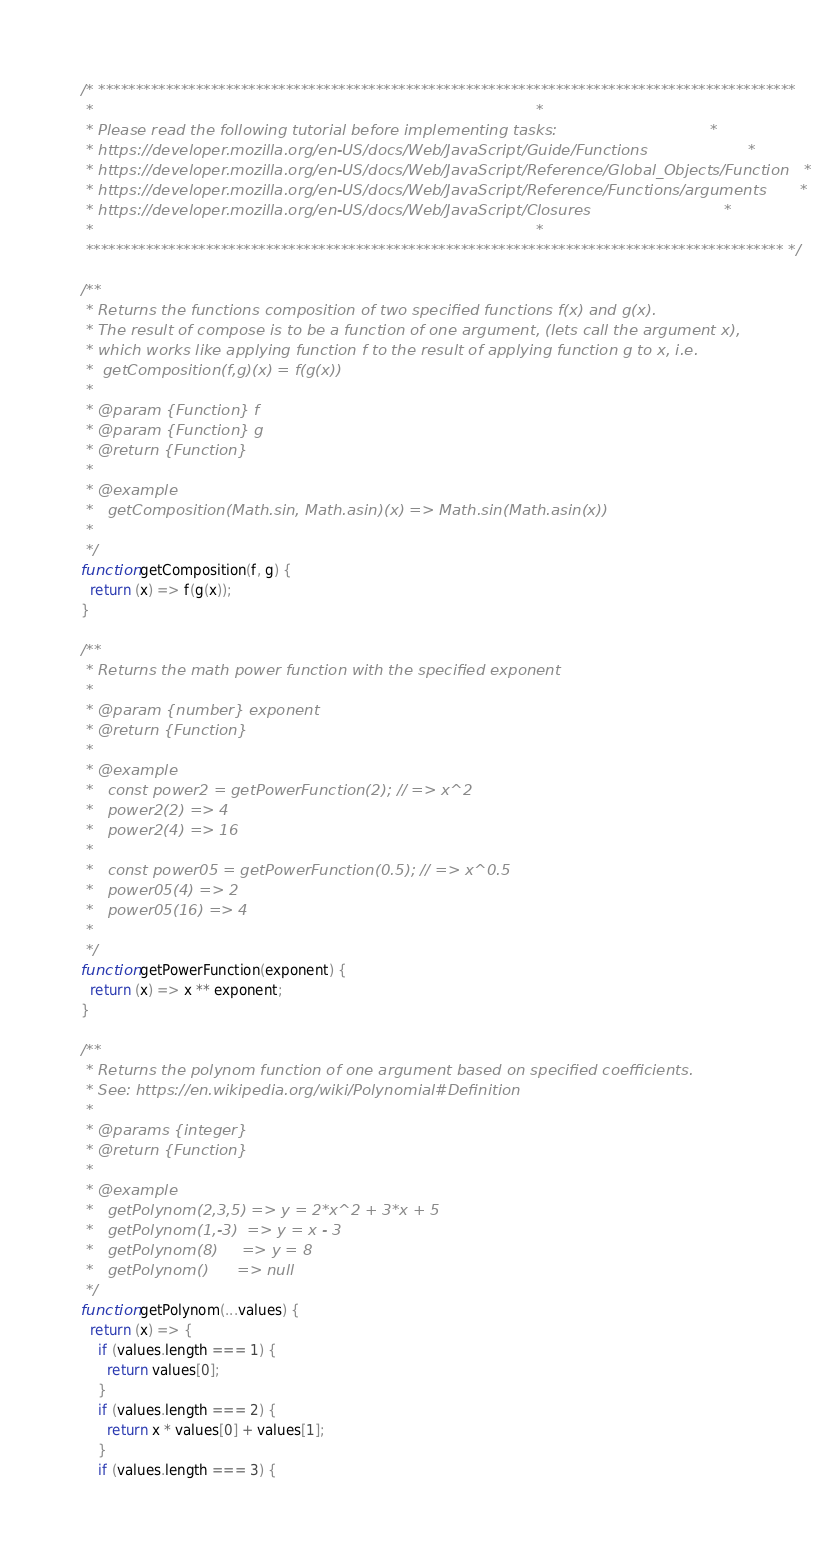Convert code to text. <code><loc_0><loc_0><loc_500><loc_500><_JavaScript_>/* *********************************************************************************************
 *                                                                                             *
 * Please read the following tutorial before implementing tasks:                                *
 * https://developer.mozilla.org/en-US/docs/Web/JavaScript/Guide/Functions                     *
 * https://developer.mozilla.org/en-US/docs/Web/JavaScript/Reference/Global_Objects/Function   *
 * https://developer.mozilla.org/en-US/docs/Web/JavaScript/Reference/Functions/arguments       *
 * https://developer.mozilla.org/en-US/docs/Web/JavaScript/Closures                            *
 *                                                                                             *
 ********************************************************************************************* */

/**
 * Returns the functions composition of two specified functions f(x) and g(x).
 * The result of compose is to be a function of one argument, (lets call the argument x),
 * which works like applying function f to the result of applying function g to x, i.e.
 *  getComposition(f,g)(x) = f(g(x))
 *
 * @param {Function} f
 * @param {Function} g
 * @return {Function}
 *
 * @example
 *   getComposition(Math.sin, Math.asin)(x) => Math.sin(Math.asin(x))
 *
 */
function getComposition(f, g) {
  return (x) => f(g(x));
}

/**
 * Returns the math power function with the specified exponent
 *
 * @param {number} exponent
 * @return {Function}
 *
 * @example
 *   const power2 = getPowerFunction(2); // => x^2
 *   power2(2) => 4
 *   power2(4) => 16
 *
 *   const power05 = getPowerFunction(0.5); // => x^0.5
 *   power05(4) => 2
 *   power05(16) => 4
 *
 */
function getPowerFunction(exponent) {
  return (x) => x ** exponent;
}

/**
 * Returns the polynom function of one argument based on specified coefficients.
 * See: https://en.wikipedia.org/wiki/Polynomial#Definition
 *
 * @params {integer}
 * @return {Function}
 *
 * @example
 *   getPolynom(2,3,5) => y = 2*x^2 + 3*x + 5
 *   getPolynom(1,-3)  => y = x - 3
 *   getPolynom(8)     => y = 8
 *   getPolynom()      => null
 */
function getPolynom(...values) {
  return (x) => {
    if (values.length === 1) {
      return values[0];
    }
    if (values.length === 2) {
      return x * values[0] + values[1];
    }
    if (values.length === 3) {</code> 